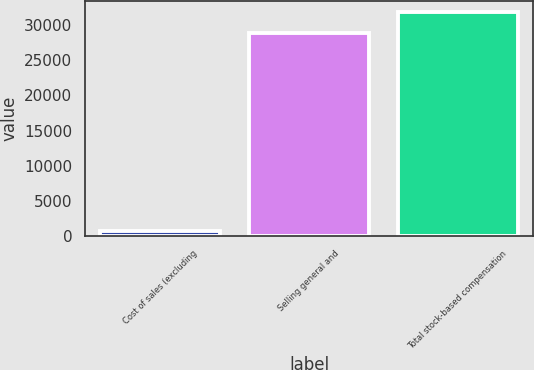<chart> <loc_0><loc_0><loc_500><loc_500><bar_chart><fcel>Cost of sales (excluding<fcel>Selling general and<fcel>Total stock-based compensation<nl><fcel>680<fcel>28944<fcel>31838.4<nl></chart> 